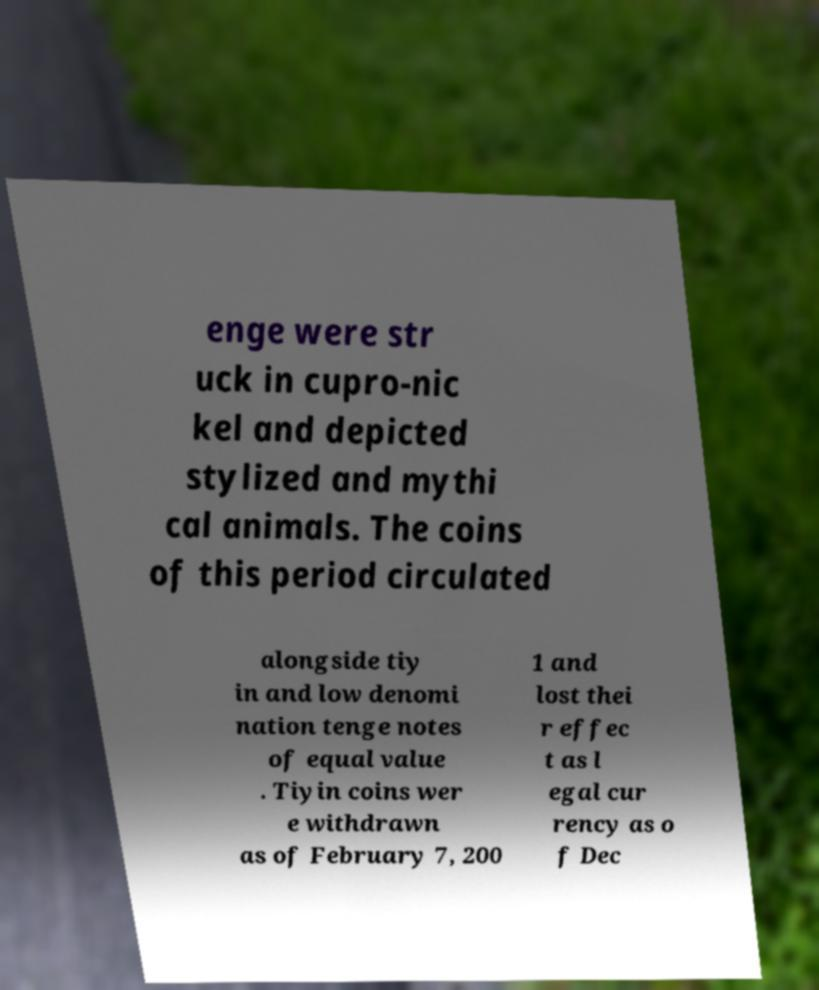Please identify and transcribe the text found in this image. enge were str uck in cupro-nic kel and depicted stylized and mythi cal animals. The coins of this period circulated alongside tiy in and low denomi nation tenge notes of equal value . Tiyin coins wer e withdrawn as of February 7, 200 1 and lost thei r effec t as l egal cur rency as o f Dec 